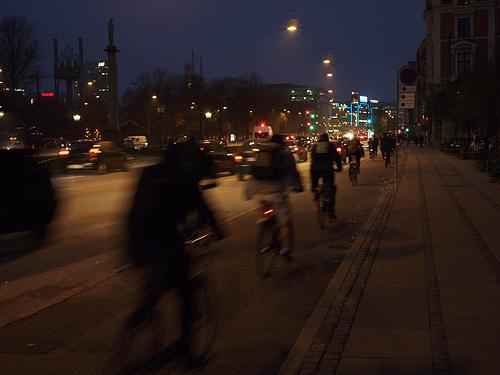In a few words, explain what is happening in the image and mention the most noticeable objects or subjects. Cyclists and cars share a night road, neon-lit buildings, sidewalk, and traffic lights visible. Imagine you are describing the image to a friend on the phone, mention the most significant elements and actions. There are people biking and cars driving on a road at night, buildings with neon lights, sidewalk, trees, and traffic lights in the city. Using a few words, describe the objects, subjects and actions in the image. City night, cars, cyclists, neon buildings, trees, lit streetlights, and empty sidewalk. Provide a short and concise description of the most prominent objects and activities in the image. People ride bikes and cars on a road at night with streetlights, neon-lit buildings, traffic lights, and sidewalk in a city scene. Summarize the main elements and actions happening in the picture. Nighttime city scene: cyclists and cars on road, neon buildings, streetlights, trees, and empty sidewalk. Describe what you see in the image, mentioning the main subjects and their actions. In the city at night, people ride bikes and cars travel on the road, lit by streetlights and surrounding neon buildings. Identify the primary subjects in the image and describe the setting. People on bikes and cars on a city road at night, streetlights, neon-lit buildings, and a sidewalk in view. Describe the scene in the image, focusing on the time and location. A nighttime city scene with cyclists and cars on the road, illuminated buildings and streetlights in the background. Write a brief sentence summarizing the key aspects of the image such as the main subjects, location, and time. Nighttime cityscape with cyclists and cars on lit road, neon buildings, trees, traffic lights, and empty sidewalk. Briefly explain what's going on in the image and any notable objects or features. Cyclists and cars navigate a nighttime city road, with neon-lit buildings, lit streetlights, and an empty sidewalk. 